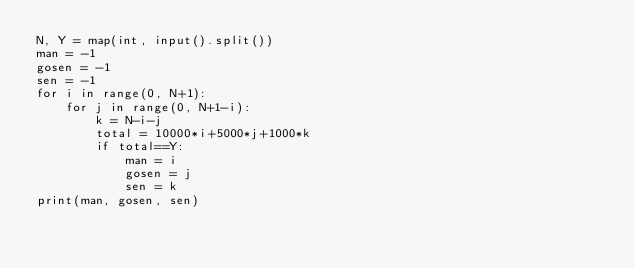Convert code to text. <code><loc_0><loc_0><loc_500><loc_500><_Python_>N, Y = map(int, input().split())
man = -1
gosen = -1
sen = -1
for i in range(0, N+1):
    for j in range(0, N+1-i):
        k = N-i-j
        total = 10000*i+5000*j+1000*k
        if total==Y:
            man = i
            gosen = j
            sen = k
print(man, gosen, sen)</code> 